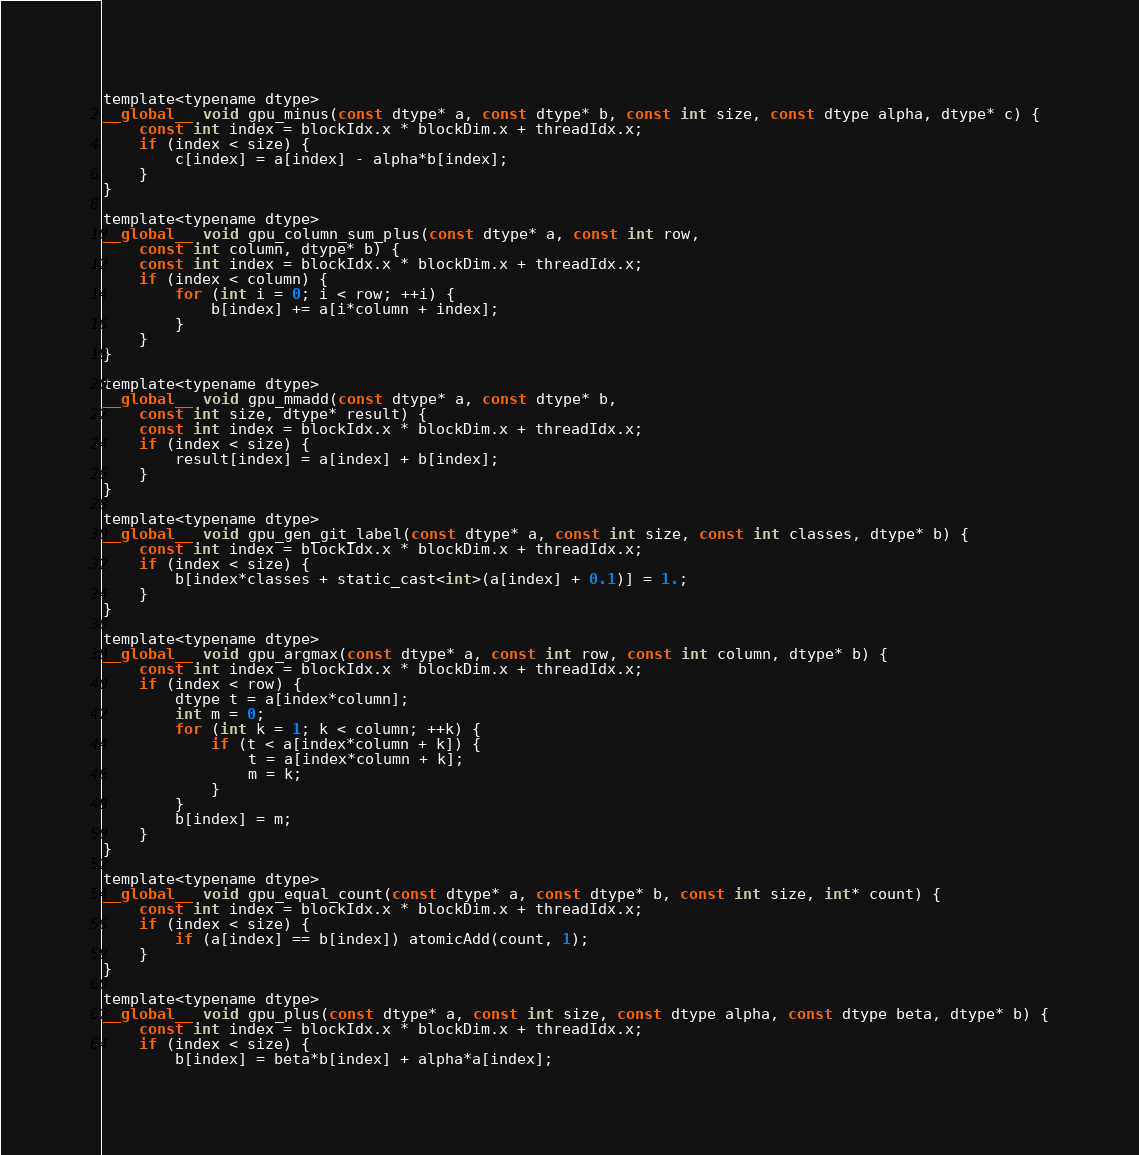Convert code to text. <code><loc_0><loc_0><loc_500><loc_500><_Cuda_>
template<typename dtype>
__global__ void gpu_minus(const dtype* a, const dtype* b, const int size, const dtype alpha, dtype* c) {
	const int index = blockIdx.x * blockDim.x + threadIdx.x;
	if (index < size) {
		c[index] = a[index] - alpha*b[index];
	}
}

template<typename dtype>
__global__ void gpu_column_sum_plus(const dtype* a, const int row, 
	const int column, dtype* b) {
	const int index = blockIdx.x * blockDim.x + threadIdx.x;
	if (index < column) {
		for (int i = 0; i < row; ++i) {
			b[index] += a[i*column + index];
		}
	}
}

template<typename dtype>
__global__ void gpu_mmadd(const dtype* a, const dtype* b,
	const int size, dtype* result) {
	const int index = blockIdx.x * blockDim.x + threadIdx.x;
	if (index < size) {
		result[index] = a[index] + b[index];
	}
}

template<typename dtype>
__global__ void gpu_gen_git_label(const dtype* a, const int size, const int classes, dtype* b) {
	const int index = blockIdx.x * blockDim.x + threadIdx.x;
	if (index < size) {
		b[index*classes + static_cast<int>(a[index] + 0.1)] = 1.;
	}
}

template<typename dtype>
__global__ void gpu_argmax(const dtype* a, const int row, const int column, dtype* b) {
	const int index = blockIdx.x * blockDim.x + threadIdx.x;
	if (index < row) {
		dtype t = a[index*column];
		int m = 0;
		for (int k = 1; k < column; ++k) {
			if (t < a[index*column + k]) {
				t = a[index*column + k];
				m = k;
			}
		}
		b[index] = m;
	}
}

template<typename dtype>
__global__ void gpu_equal_count(const dtype* a, const dtype* b, const int size, int* count) {
	const int index = blockIdx.x * blockDim.x + threadIdx.x;
	if (index < size) {
		if (a[index] == b[index]) atomicAdd(count, 1);
	}
}

template<typename dtype>
__global__ void gpu_plus(const dtype* a, const int size, const dtype alpha, const dtype beta, dtype* b) {
	const int index = blockIdx.x * blockDim.x + threadIdx.x;
	if (index < size) {
		b[index] = beta*b[index] + alpha*a[index];</code> 